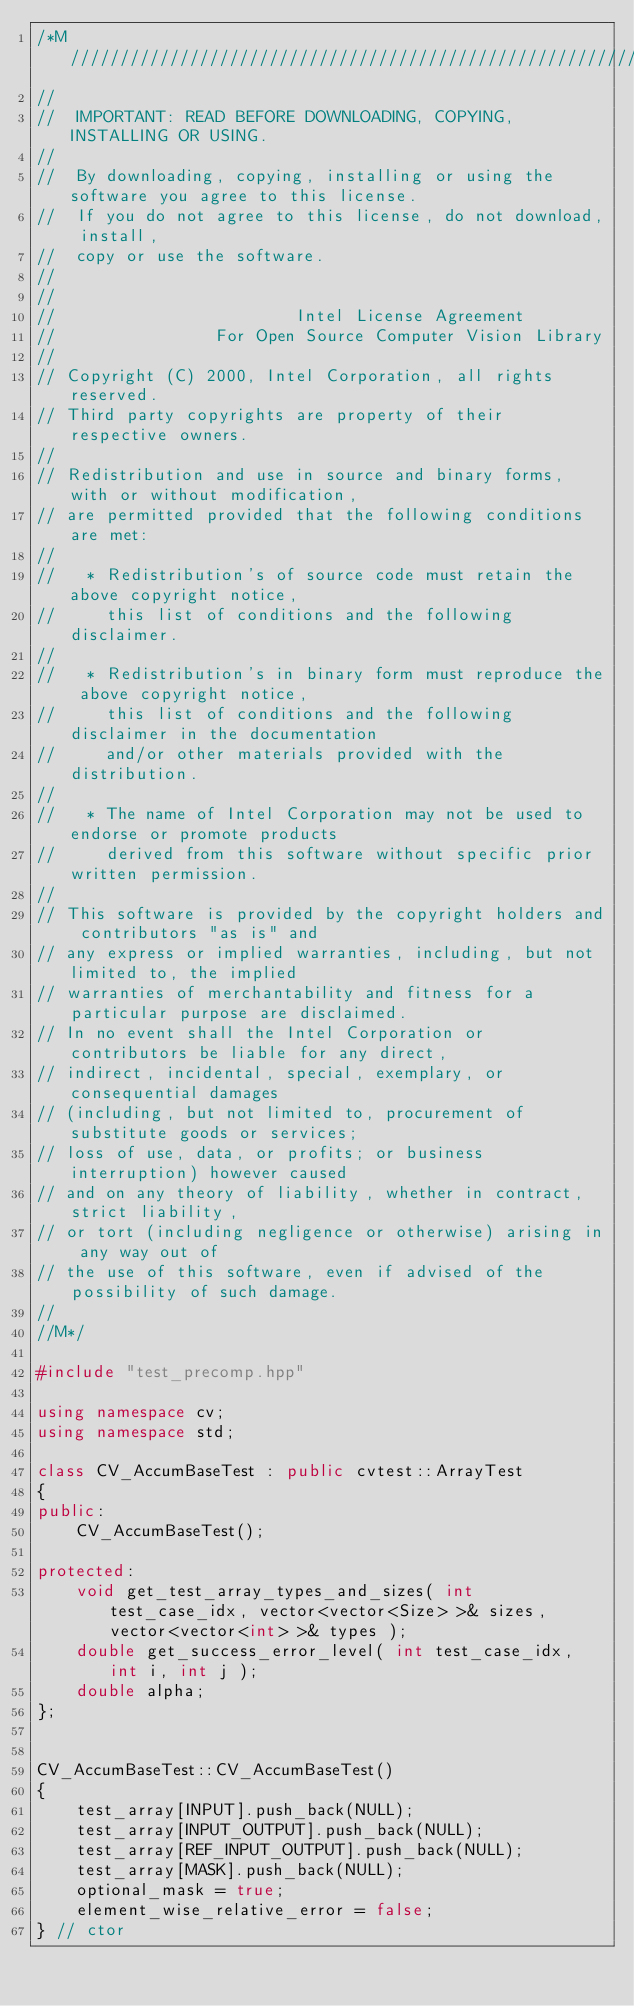<code> <loc_0><loc_0><loc_500><loc_500><_C++_>/*M///////////////////////////////////////////////////////////////////////////////////////
//
//  IMPORTANT: READ BEFORE DOWNLOADING, COPYING, INSTALLING OR USING.
//
//  By downloading, copying, installing or using the software you agree to this license.
//  If you do not agree to this license, do not download, install,
//  copy or use the software.
//
//
//                        Intel License Agreement
//                For Open Source Computer Vision Library
//
// Copyright (C) 2000, Intel Corporation, all rights reserved.
// Third party copyrights are property of their respective owners.
//
// Redistribution and use in source and binary forms, with or without modification,
// are permitted provided that the following conditions are met:
//
//   * Redistribution's of source code must retain the above copyright notice,
//     this list of conditions and the following disclaimer.
//
//   * Redistribution's in binary form must reproduce the above copyright notice,
//     this list of conditions and the following disclaimer in the documentation
//     and/or other materials provided with the distribution.
//
//   * The name of Intel Corporation may not be used to endorse or promote products
//     derived from this software without specific prior written permission.
//
// This software is provided by the copyright holders and contributors "as is" and
// any express or implied warranties, including, but not limited to, the implied
// warranties of merchantability and fitness for a particular purpose are disclaimed.
// In no event shall the Intel Corporation or contributors be liable for any direct,
// indirect, incidental, special, exemplary, or consequential damages
// (including, but not limited to, procurement of substitute goods or services;
// loss of use, data, or profits; or business interruption) however caused
// and on any theory of liability, whether in contract, strict liability,
// or tort (including negligence or otherwise) arising in any way out of
// the use of this software, even if advised of the possibility of such damage.
//
//M*/

#include "test_precomp.hpp"

using namespace cv;
using namespace std;

class CV_AccumBaseTest : public cvtest::ArrayTest
{
public:
    CV_AccumBaseTest();

protected:
    void get_test_array_types_and_sizes( int test_case_idx, vector<vector<Size> >& sizes, vector<vector<int> >& types );
    double get_success_error_level( int test_case_idx, int i, int j );
    double alpha;
};


CV_AccumBaseTest::CV_AccumBaseTest()
{
    test_array[INPUT].push_back(NULL);
    test_array[INPUT_OUTPUT].push_back(NULL);
    test_array[REF_INPUT_OUTPUT].push_back(NULL);
    test_array[MASK].push_back(NULL);
    optional_mask = true;
    element_wise_relative_error = false;
} // ctor

</code> 